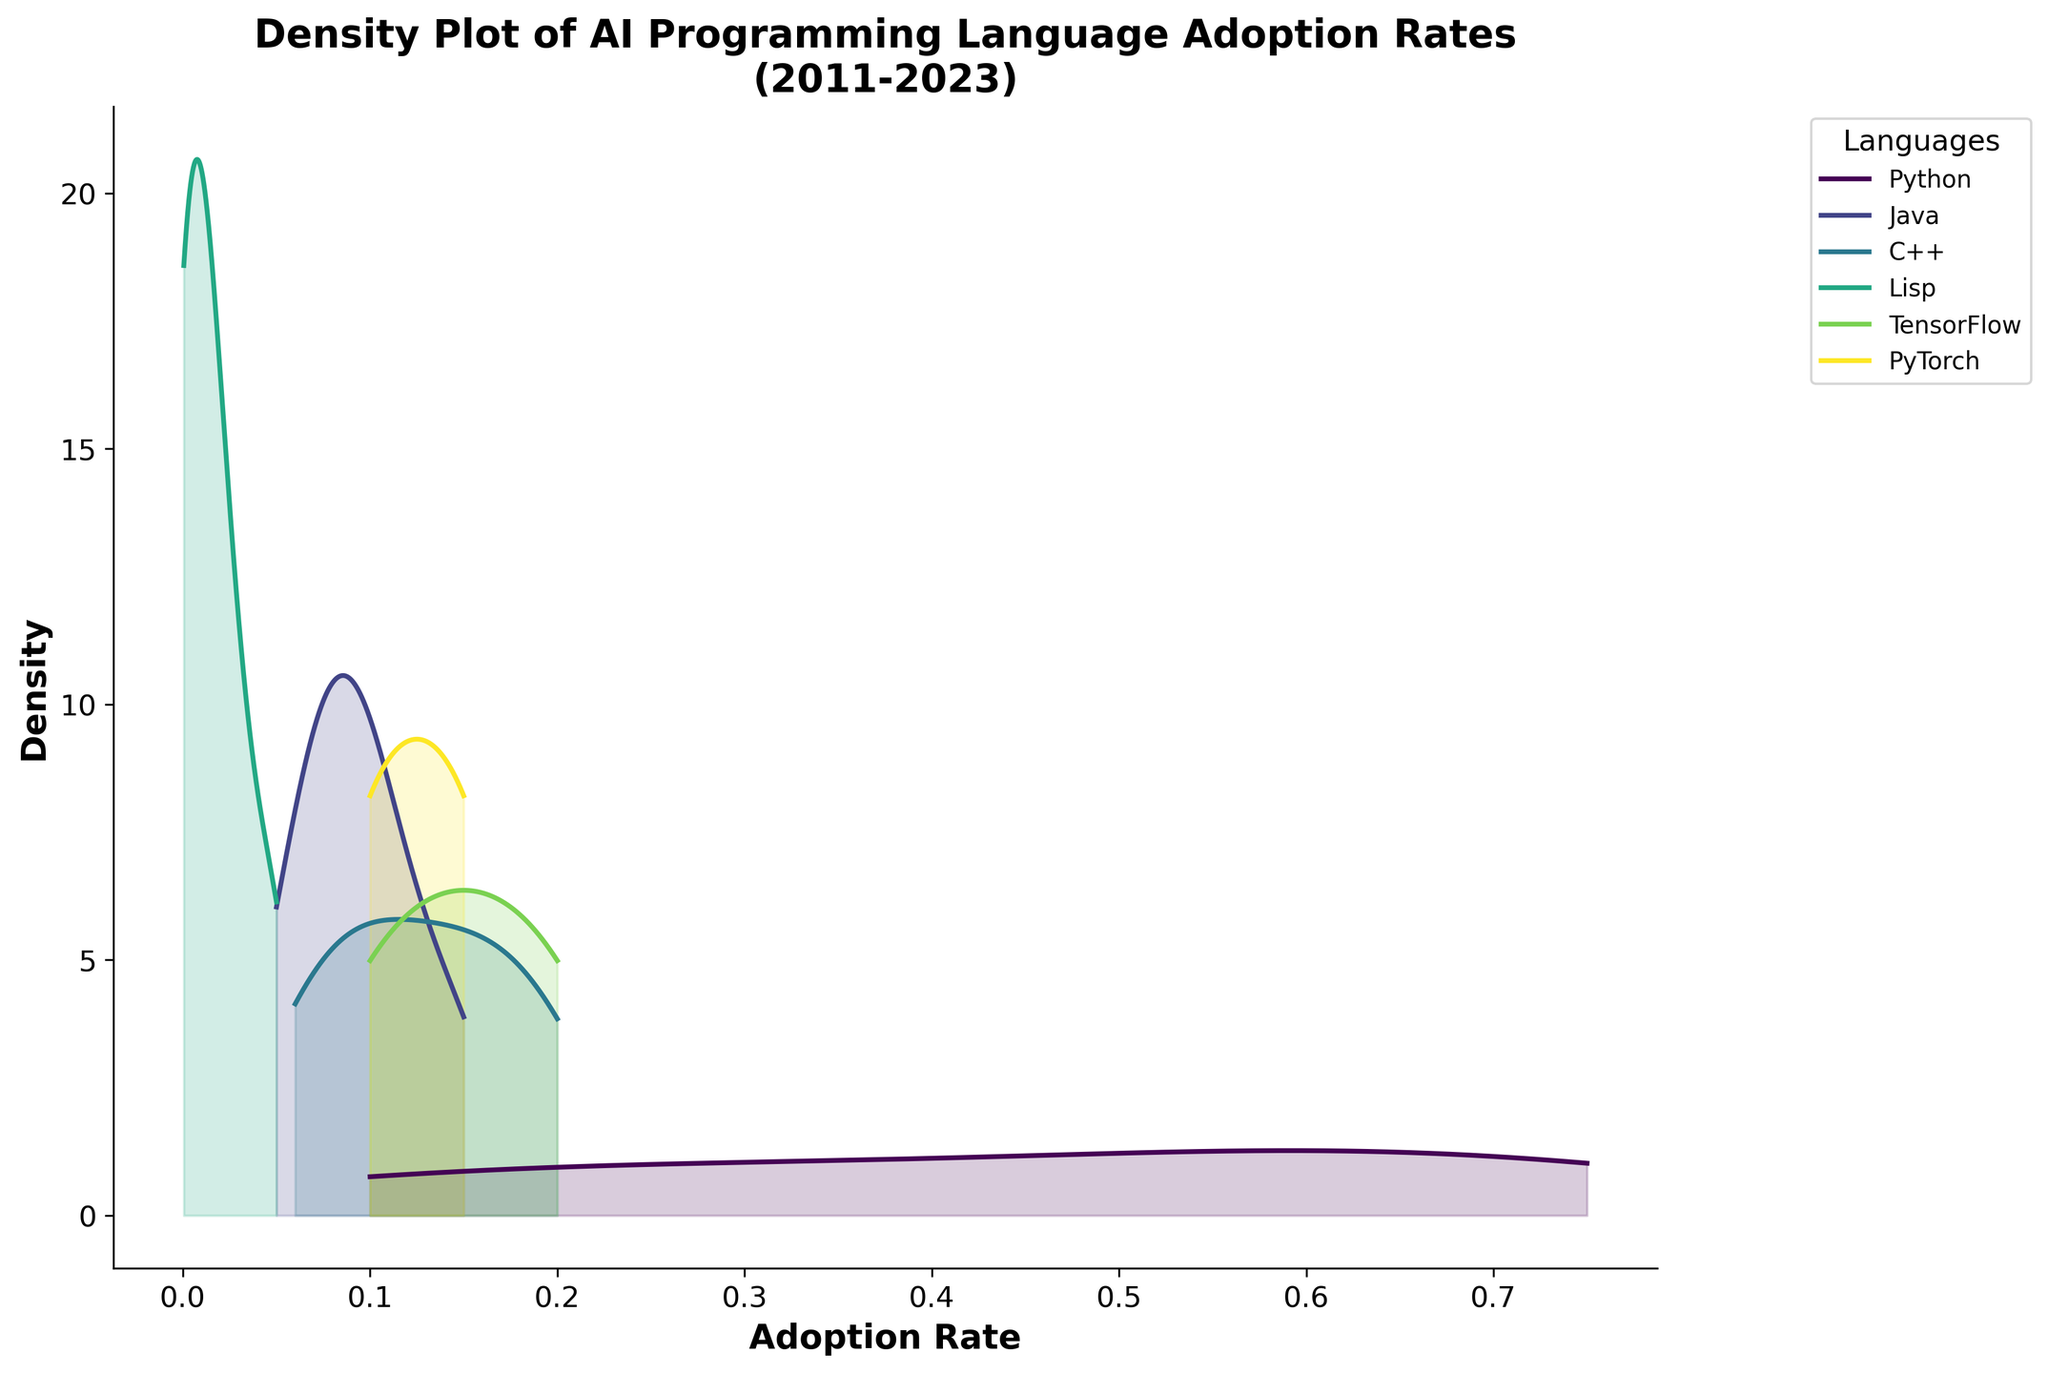What is the title of the figure? The title is the text that appears at the top of the figure.
Answer: Density Plot of AI Programming Language Adoption Rates (2011-2023) Which language has the highest density peak in adoption rate? Python's density peak appears to be the highest compared to the other languages.
Answer: Python What is the range of adoption rates for Java observed in the figure? The density plot shows that Java's adoption rates vary from approximately 0.05 to 0.15.
Answer: 0.05 to 0.15 Which two languages show a significant increase in adoption rate from 2011 to 2023? By examining the plot, Python and TensorFlow show significant increases in adoption rate compared to other languages.
Answer: Python and TensorFlow What is the adoption rate of Lisp in 2023? Look for the data points related to Lisp in the year 2023.
Answer: 0.0005 How does the adoption rate of PyTorch in 2023 compare to that in 2021? Look for the density peaks corresponding to PyTorch for the years 2021 and 2023; 2023's peak is slightly higher.
Answer: Higher By how much has Python's adoption rate increased from 2011 to 2023? From the data, Python's rate increased from 0.10 in 2011 to 0.75 in 2023. The increase is 0.75 - 0.10.
Answer: 0.65 Which language had the lowest adoption rate in 2021? Check for the lowest density peak in the year 2021.
Answer: Lisp What pattern can you observe about Java's adoption rate trend over the years? Java's adoption rate shows a consistent decline from 2011 to 2023 based on the decreasing density peak trend.
Answer: Declining trend 